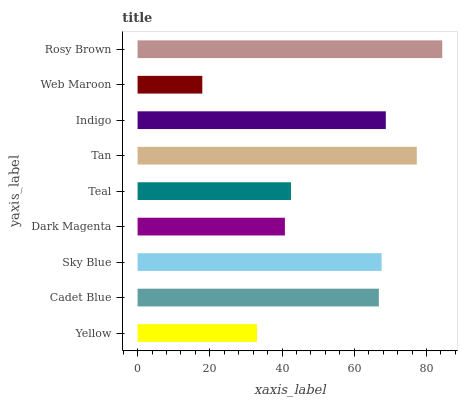Is Web Maroon the minimum?
Answer yes or no. Yes. Is Rosy Brown the maximum?
Answer yes or no. Yes. Is Cadet Blue the minimum?
Answer yes or no. No. Is Cadet Blue the maximum?
Answer yes or no. No. Is Cadet Blue greater than Yellow?
Answer yes or no. Yes. Is Yellow less than Cadet Blue?
Answer yes or no. Yes. Is Yellow greater than Cadet Blue?
Answer yes or no. No. Is Cadet Blue less than Yellow?
Answer yes or no. No. Is Cadet Blue the high median?
Answer yes or no. Yes. Is Cadet Blue the low median?
Answer yes or no. Yes. Is Rosy Brown the high median?
Answer yes or no. No. Is Indigo the low median?
Answer yes or no. No. 